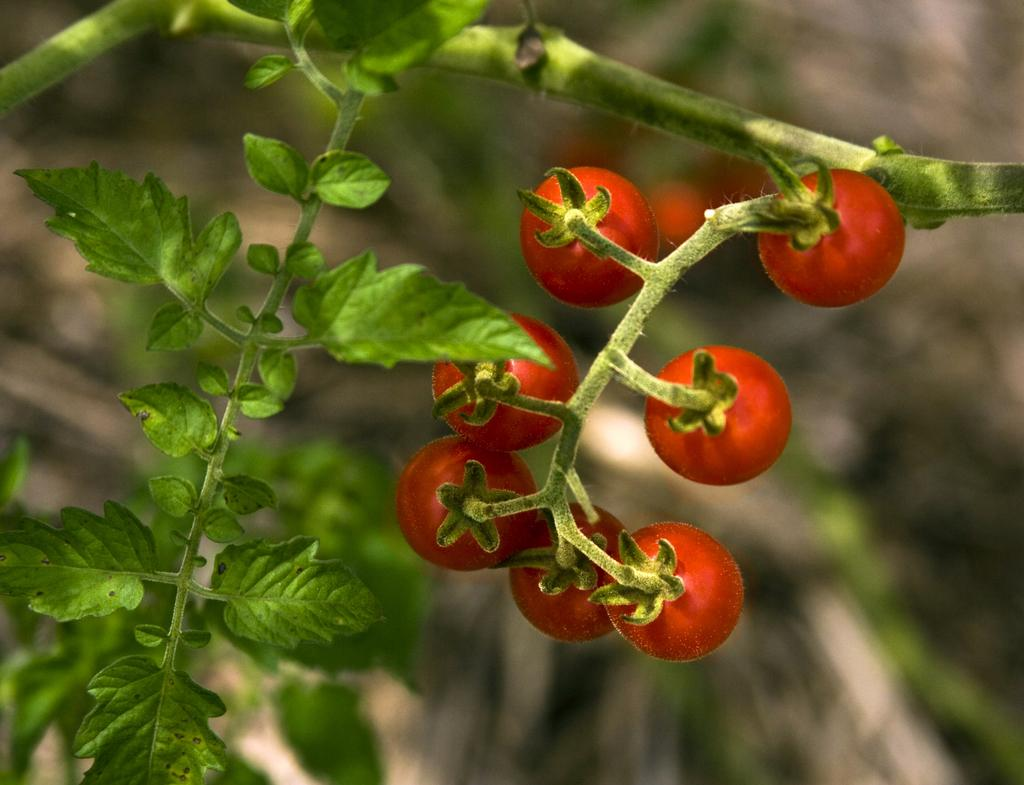What type of fruit can be seen in the image? There are tomatoes in the image. What else is present in the image besides the tomatoes? There are leaves in the image. What type of shelf can be seen in the image? There is no shelf present in the image. 